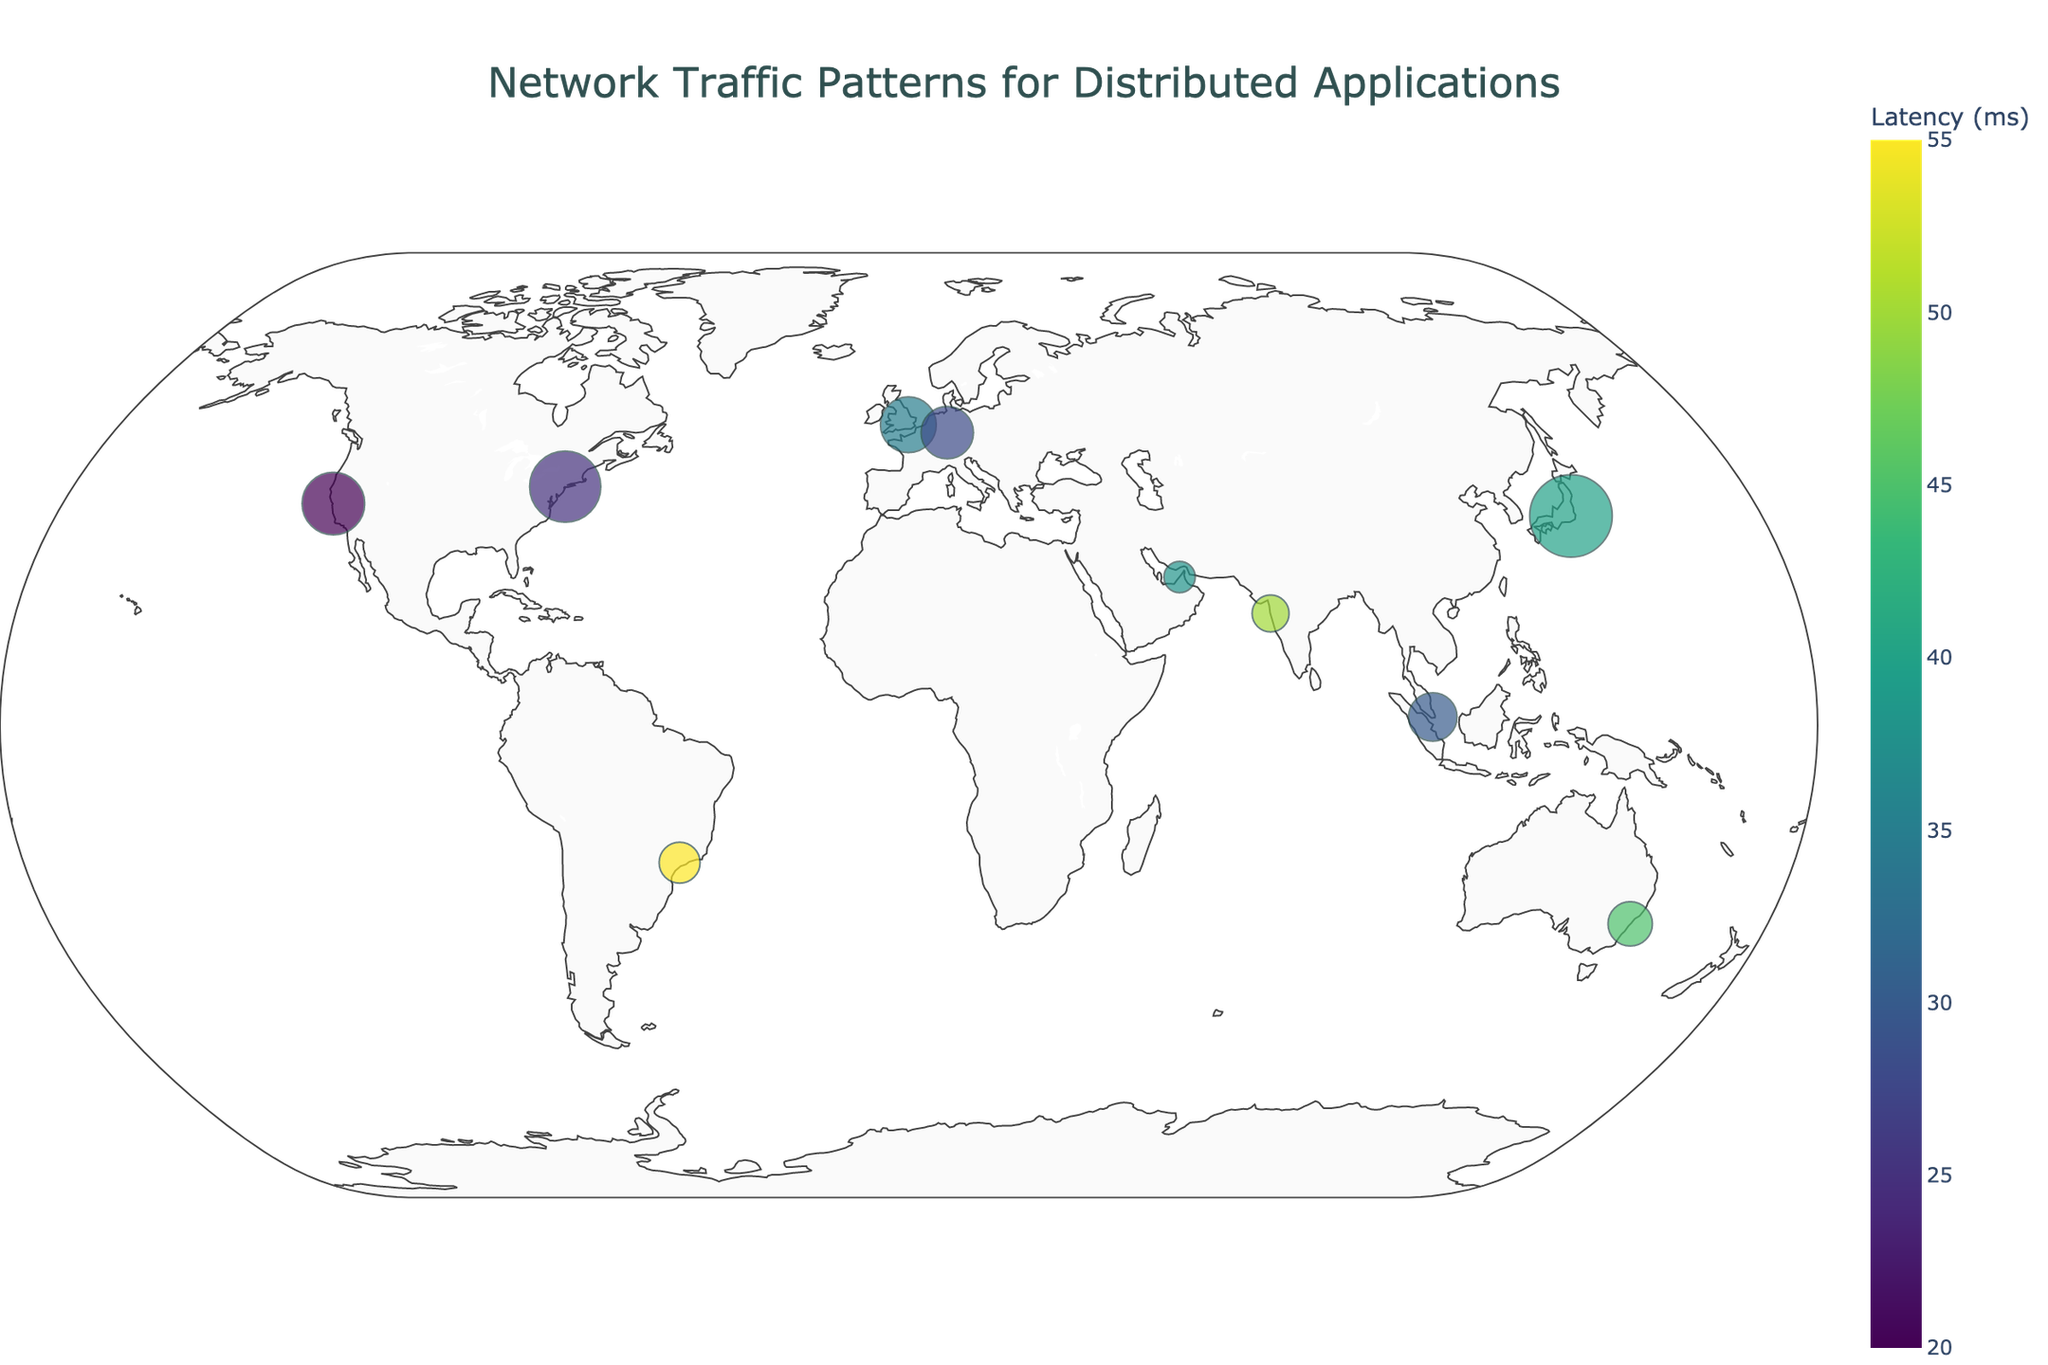What's the title of the plot? The title of the plot is located at the top center, with a larger font size and darker color. It summarizes the main focus of the visual representation.
Answer: Network Traffic Patterns for Distributed Applications Which location has the highest average traffic? To determine the location with the highest average traffic, look at the size of the markers on the map as they represent the average traffic. The largest marker corresponds to the location with the highest traffic. In this case, it's Tokyo.
Answer: Tokyo What is the latency in milliseconds in Tokyo? The color of the markers represents the latency. The color bar on the right side of the plot helps decode the latency value. For Tokyo, the color corresponds to a latency of 40 ms, also annotated in the tooltip when hovering over the marker.
Answer: 40 ms List all locations that have a latency greater than 40 ms. To find locations with latency greater than 40 ms, use the color of the markers compared against the color bar. Locations with latency greater than 40 ms are Sydney, Mumbai, and São Paulo.
Answer: Sydney, Mumbai, São Paulo Which location has the smallest number of servers? The tooltip contains information about the number of servers when hovering over the markers. The place with the fewest servers, which is Dubai, has 20 servers.
Answer: Dubai What is the peak traffic hour range in London? By hovering over the London marker, the tooltip shows the details of peak hours traffic time, identified as "09:00-13:00" in the plot annotations.
Answer: 09:00-13:00 Which city has the closest average traffic to 1000 MB? Observing marker sizes and tooltips reveals that San Francisco, with 1100 MB, is the closest city to the given average traffic of 1000 MB.
Answer: San Francisco What is the difference in latency between Sydney and Dubai? Hovering over markers to get their respective latencies shows that Sydney has a latency of 45 ms, while Dubai has 38 ms. The difference is 45 - 38 = 7 ms.
Answer: 7 ms Compare the average traffic between New York and San Francisco. Which one is higher and by how much? Checking the size of markers and tooltips shows New York has an average traffic of 1250 MB and San Francisco has 1100 MB. The difference is 1250 MB - 1100 MB = 150 MB, so New York has higher traffic by 150 MB.
Answer: New York by 150 MB Which location has the most servers? Tooltip annotations show that Tokyo has the most servers with a count of 52 servers.
Answer: Tokyo 